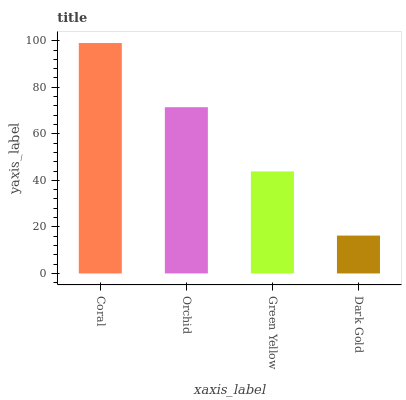Is Dark Gold the minimum?
Answer yes or no. Yes. Is Coral the maximum?
Answer yes or no. Yes. Is Orchid the minimum?
Answer yes or no. No. Is Orchid the maximum?
Answer yes or no. No. Is Coral greater than Orchid?
Answer yes or no. Yes. Is Orchid less than Coral?
Answer yes or no. Yes. Is Orchid greater than Coral?
Answer yes or no. No. Is Coral less than Orchid?
Answer yes or no. No. Is Orchid the high median?
Answer yes or no. Yes. Is Green Yellow the low median?
Answer yes or no. Yes. Is Green Yellow the high median?
Answer yes or no. No. Is Dark Gold the low median?
Answer yes or no. No. 